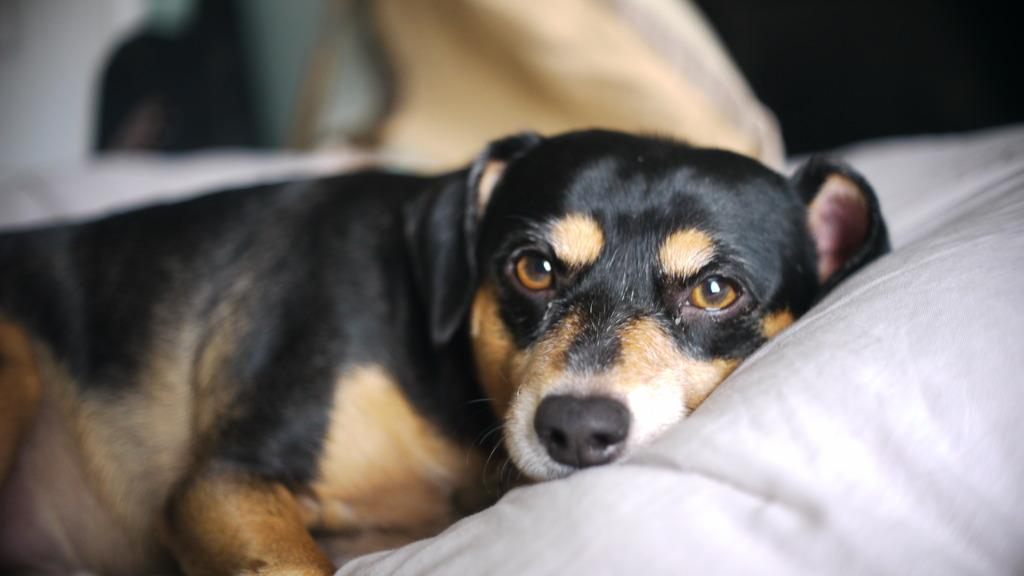What type of animal is in the image? There is a dog in the image. What is the dog doing in the image? The dog is lying on a bed. Can you describe the background of the image? The background of the image is blurry. What type of reason do the fairies use to justify their actions in the image? There are no fairies present in the image, so it is not possible to determine the type of reason they might use. 